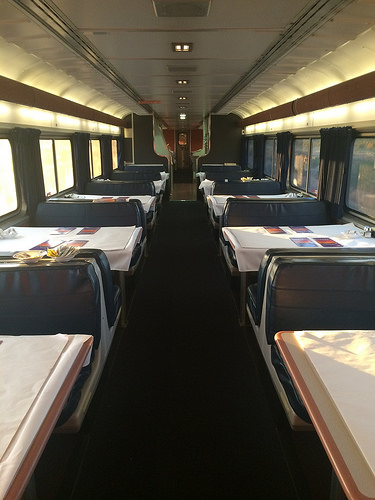<image>
Is the carpet in the train? Yes. The carpet is contained within or inside the train, showing a containment relationship. Where is the window in relation to the table? Is it to the left of the table? No. The window is not to the left of the table. From this viewpoint, they have a different horizontal relationship. 